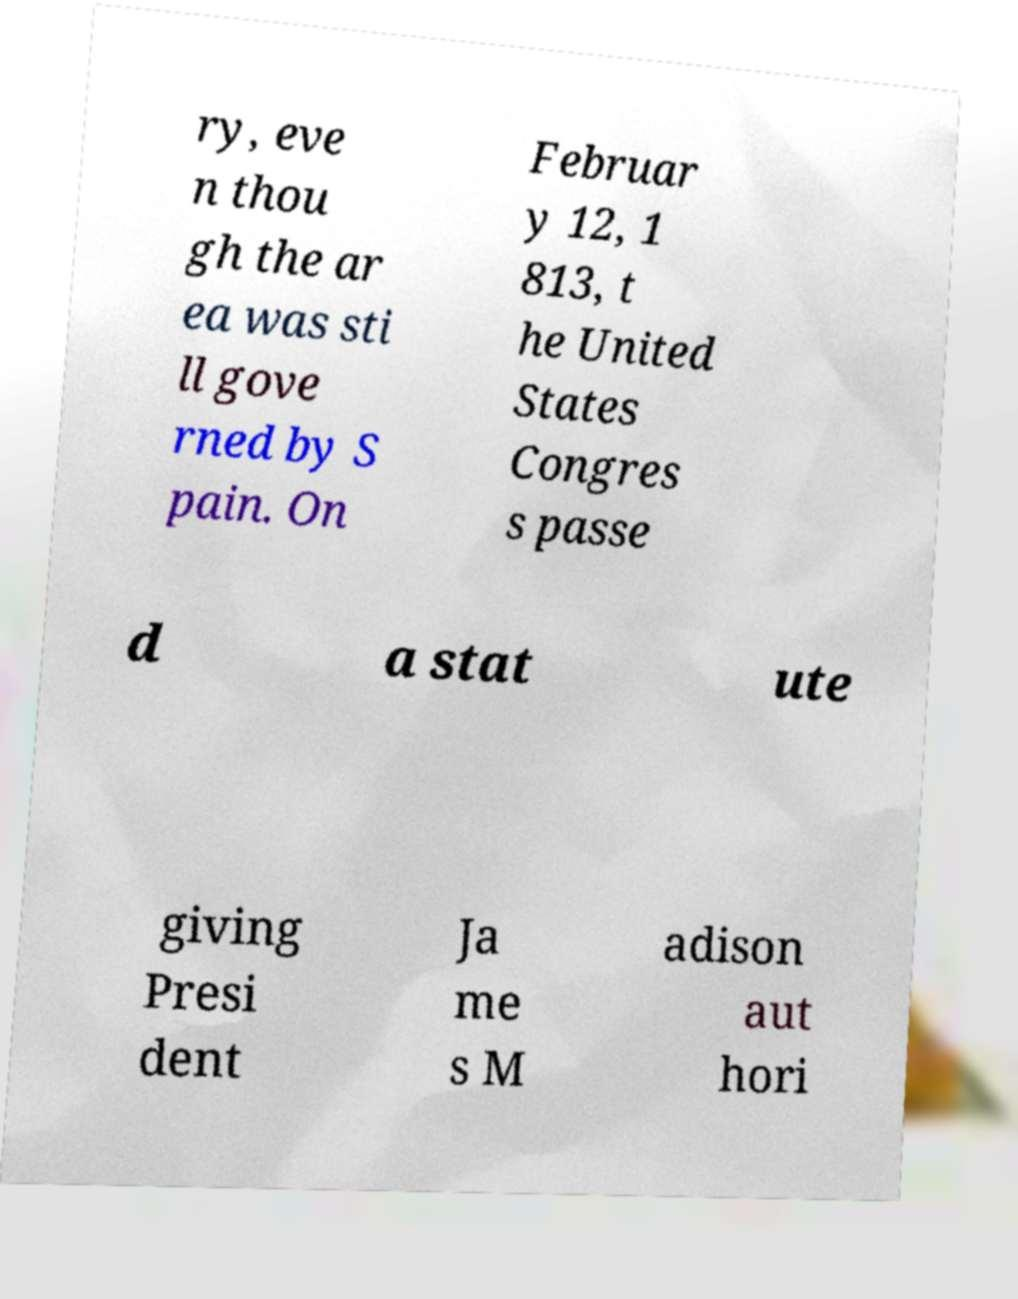Could you extract and type out the text from this image? ry, eve n thou gh the ar ea was sti ll gove rned by S pain. On Februar y 12, 1 813, t he United States Congres s passe d a stat ute giving Presi dent Ja me s M adison aut hori 